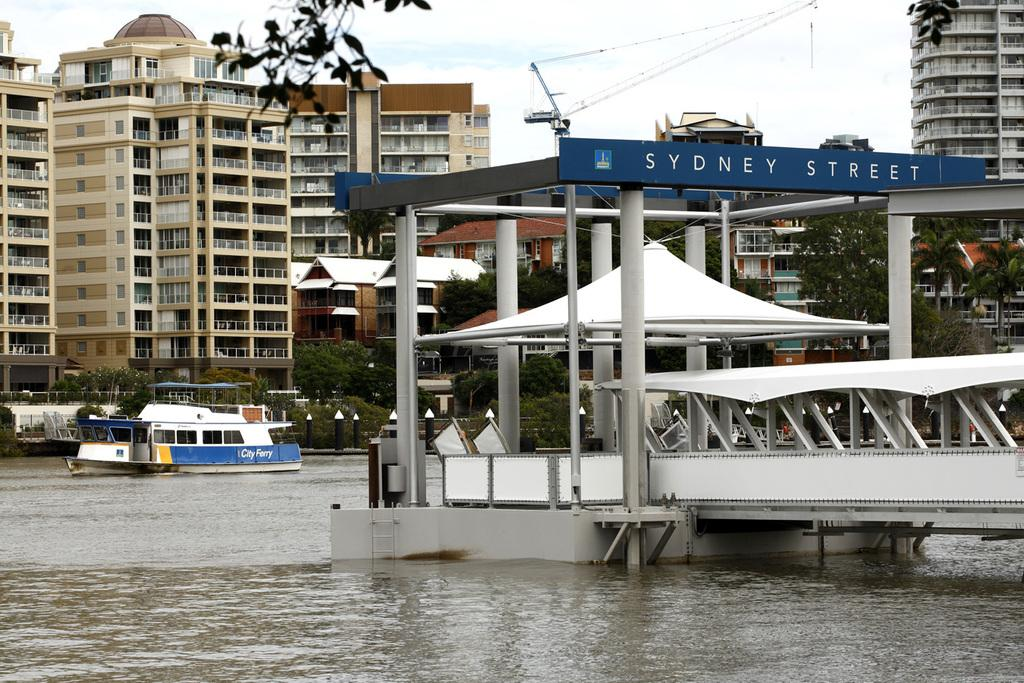What is the main subject of the image? The main subject of the image is a boat on the water. What other structures or objects can be seen in the image? There is a bridge, poles, boards, buildings, trees, railings, and the sky is visible at the top of the image. What type of smile can be seen on the trees in the image? There are no smiles present on the trees in the image, as trees do not have facial expressions. 